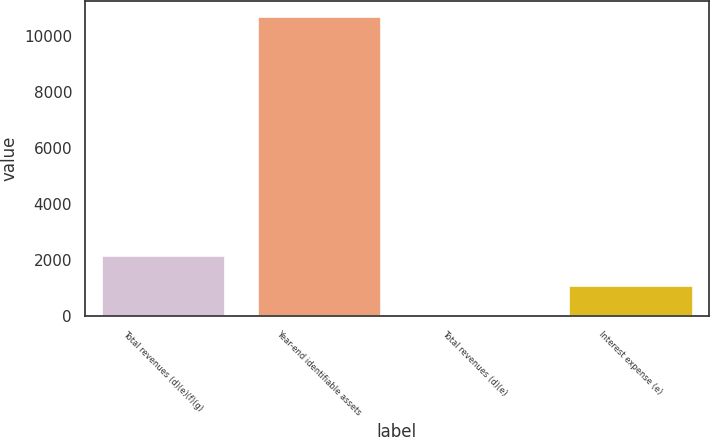Convert chart to OTSL. <chart><loc_0><loc_0><loc_500><loc_500><bar_chart><fcel>Total revenues (d)(e)(f)(g)<fcel>Year-end identifiable assets<fcel>Total revenues (d)(e)<fcel>Interest expense (e)<nl><fcel>2169.2<fcel>10742<fcel>26<fcel>1097.6<nl></chart> 